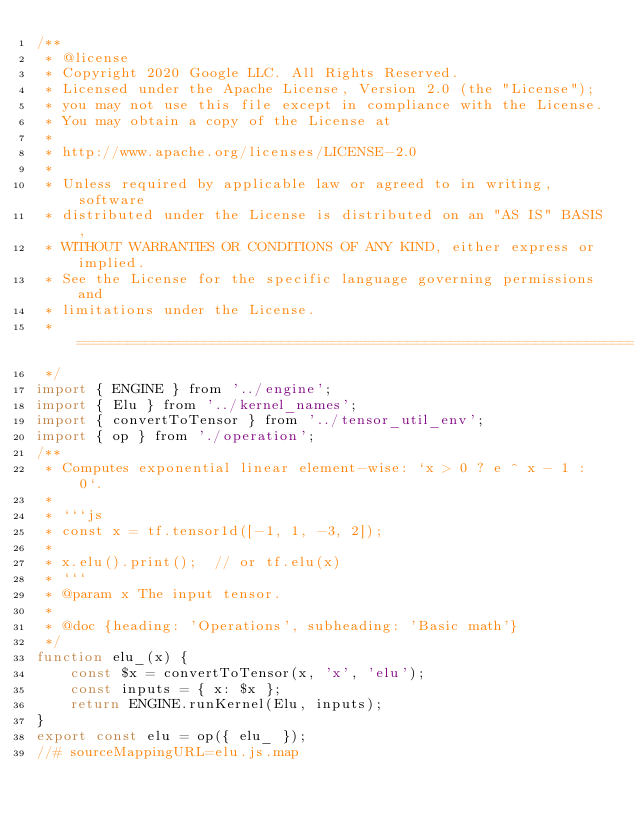Convert code to text. <code><loc_0><loc_0><loc_500><loc_500><_JavaScript_>/**
 * @license
 * Copyright 2020 Google LLC. All Rights Reserved.
 * Licensed under the Apache License, Version 2.0 (the "License");
 * you may not use this file except in compliance with the License.
 * You may obtain a copy of the License at
 *
 * http://www.apache.org/licenses/LICENSE-2.0
 *
 * Unless required by applicable law or agreed to in writing, software
 * distributed under the License is distributed on an "AS IS" BASIS,
 * WITHOUT WARRANTIES OR CONDITIONS OF ANY KIND, either express or implied.
 * See the License for the specific language governing permissions and
 * limitations under the License.
 * =============================================================================
 */
import { ENGINE } from '../engine';
import { Elu } from '../kernel_names';
import { convertToTensor } from '../tensor_util_env';
import { op } from './operation';
/**
 * Computes exponential linear element-wise: `x > 0 ? e ^ x - 1 : 0`.
 *
 * ```js
 * const x = tf.tensor1d([-1, 1, -3, 2]);
 *
 * x.elu().print();  // or tf.elu(x)
 * ```
 * @param x The input tensor.
 *
 * @doc {heading: 'Operations', subheading: 'Basic math'}
 */
function elu_(x) {
    const $x = convertToTensor(x, 'x', 'elu');
    const inputs = { x: $x };
    return ENGINE.runKernel(Elu, inputs);
}
export const elu = op({ elu_ });
//# sourceMappingURL=elu.js.map</code> 